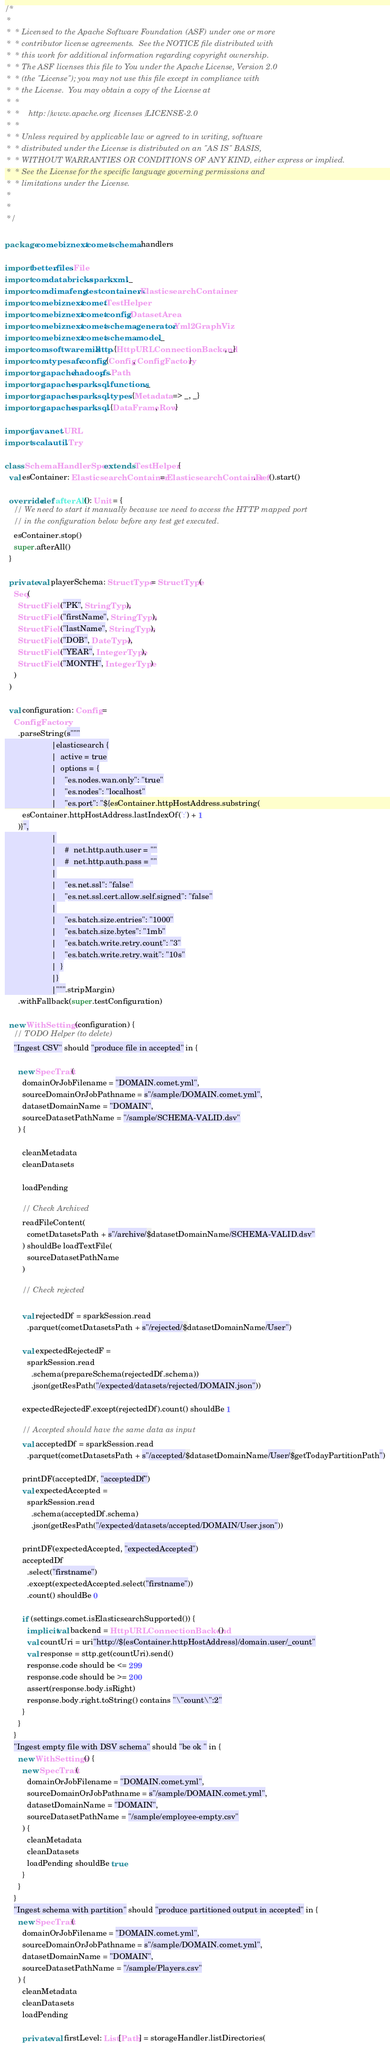<code> <loc_0><loc_0><loc_500><loc_500><_Scala_>/*
 *
 *  * Licensed to the Apache Software Foundation (ASF) under one or more
 *  * contributor license agreements.  See the NOTICE file distributed with
 *  * this work for additional information regarding copyright ownership.
 *  * The ASF licenses this file to You under the Apache License, Version 2.0
 *  * (the "License"); you may not use this file except in compliance with
 *  * the License.  You may obtain a copy of the License at
 *  *
 *  *    http://www.apache.org/licenses/LICENSE-2.0
 *  *
 *  * Unless required by applicable law or agreed to in writing, software
 *  * distributed under the License is distributed on an "AS IS" BASIS,
 *  * WITHOUT WARRANTIES OR CONDITIONS OF ANY KIND, either express or implied.
 *  * See the License for the specific language governing permissions and
 *  * limitations under the License.
 *
 *
 */

package com.ebiznext.comet.schema.handlers

import better.files.File
import com.databricks.spark.xml._
import com.dimafeng.testcontainers.ElasticsearchContainer
import com.ebiznext.comet.TestHelper
import com.ebiznext.comet.config.DatasetArea
import com.ebiznext.comet.schema.generator.Yml2GraphViz
import com.ebiznext.comet.schema.model._
import com.softwaremill.sttp.{HttpURLConnectionBackend, _}
import com.typesafe.config.{Config, ConfigFactory}
import org.apache.hadoop.fs.Path
import org.apache.spark.sql.functions._
import org.apache.spark.sql.types.{Metadata => _, _}
import org.apache.spark.sql.{DataFrame, Row}

import java.net.URL
import scala.util.Try

class SchemaHandlerSpec extends TestHelper {
  val esContainer: ElasticsearchContainer = ElasticsearchContainer.Def().start()

  override def afterAll(): Unit = {
    // We need to start it manually because we need to access the HTTP mapped port
    // in the configuration below before any test get executed.
    esContainer.stop()
    super.afterAll()
  }

  private val playerSchema: StructType = StructType(
    Seq(
      StructField("PK", StringType),
      StructField("firstName", StringType),
      StructField("lastName", StringType),
      StructField("DOB", DateType),
      StructField("YEAR", IntegerType),
      StructField("MONTH", IntegerType)
    )
  )

  val configuration: Config =
    ConfigFactory
      .parseString(s"""
                     |elasticsearch {
                     |  active = true
                     |  options = {
                     |    "es.nodes.wan.only": "true"
                     |    "es.nodes": "localhost"
                     |    "es.port": "${esContainer.httpHostAddress.substring(
        esContainer.httpHostAddress.lastIndexOf(':') + 1
      )}",
                     |
                     |    #  net.http.auth.user = ""
                     |    #  net.http.auth.pass = ""
                     |
                     |    "es.net.ssl": "false"
                     |    "es.net.ssl.cert.allow.self.signed": "false"
                     |
                     |    "es.batch.size.entries": "1000"
                     |    "es.batch.size.bytes": "1mb"
                     |    "es.batch.write.retry.count": "3"
                     |    "es.batch.write.retry.wait": "10s"
                     |  }
                     |}
                     |""".stripMargin)
      .withFallback(super.testConfiguration)

  new WithSettings(configuration) {
    // TODO Helper (to delete)
    "Ingest CSV" should "produce file in accepted" in {

      new SpecTrait(
        domainOrJobFilename = "DOMAIN.comet.yml",
        sourceDomainOrJobPathname = s"/sample/DOMAIN.comet.yml",
        datasetDomainName = "DOMAIN",
        sourceDatasetPathName = "/sample/SCHEMA-VALID.dsv"
      ) {

        cleanMetadata
        cleanDatasets

        loadPending

        // Check Archived
        readFileContent(
          cometDatasetsPath + s"/archive/$datasetDomainName/SCHEMA-VALID.dsv"
        ) shouldBe loadTextFile(
          sourceDatasetPathName
        )

        // Check rejected

        val rejectedDf = sparkSession.read
          .parquet(cometDatasetsPath + s"/rejected/$datasetDomainName/User")

        val expectedRejectedF =
          sparkSession.read
            .schema(prepareSchema(rejectedDf.schema))
            .json(getResPath("/expected/datasets/rejected/DOMAIN.json"))

        expectedRejectedF.except(rejectedDf).count() shouldBe 1

        // Accepted should have the same data as input
        val acceptedDf = sparkSession.read
          .parquet(cometDatasetsPath + s"/accepted/$datasetDomainName/User/$getTodayPartitionPath")

        printDF(acceptedDf, "acceptedDf")
        val expectedAccepted =
          sparkSession.read
            .schema(acceptedDf.schema)
            .json(getResPath("/expected/datasets/accepted/DOMAIN/User.json"))

        printDF(expectedAccepted, "expectedAccepted")
        acceptedDf
          .select("firstname")
          .except(expectedAccepted.select("firstname"))
          .count() shouldBe 0

        if (settings.comet.isElasticsearchSupported()) {
          implicit val backend = HttpURLConnectionBackend()
          val countUri = uri"http://${esContainer.httpHostAddress}/domain.user/_count"
          val response = sttp.get(countUri).send()
          response.code should be <= 299
          response.code should be >= 200
          assert(response.body.isRight)
          response.body.right.toString() contains "\"count\":2"
        }
      }
    }
    "Ingest empty file with DSV schema" should "be ok " in {
      new WithSettings() {
        new SpecTrait(
          domainOrJobFilename = "DOMAIN.comet.yml",
          sourceDomainOrJobPathname = s"/sample/DOMAIN.comet.yml",
          datasetDomainName = "DOMAIN",
          sourceDatasetPathName = "/sample/employee-empty.csv"
        ) {
          cleanMetadata
          cleanDatasets
          loadPending shouldBe true
        }
      }
    }
    "Ingest schema with partition" should "produce partitioned output in accepted" in {
      new SpecTrait(
        domainOrJobFilename = "DOMAIN.comet.yml",
        sourceDomainOrJobPathname = s"/sample/DOMAIN.comet.yml",
        datasetDomainName = "DOMAIN",
        sourceDatasetPathName = "/sample/Players.csv"
      ) {
        cleanMetadata
        cleanDatasets
        loadPending

        private val firstLevel: List[Path] = storageHandler.listDirectories(</code> 